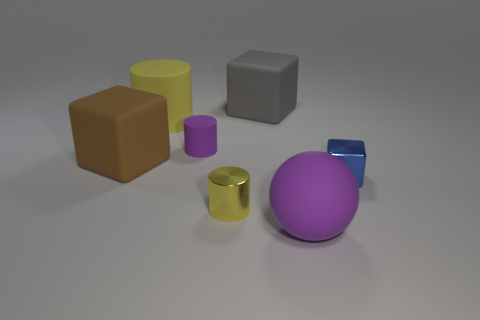Subtract 1 cylinders. How many cylinders are left? 2 Subtract all small yellow metallic cylinders. How many cylinders are left? 2 Add 2 big matte things. How many objects exist? 9 Subtract all cylinders. How many objects are left? 4 Subtract 0 blue cylinders. How many objects are left? 7 Subtract all blue objects. Subtract all tiny blue objects. How many objects are left? 5 Add 4 rubber cubes. How many rubber cubes are left? 6 Add 2 tiny cyan metal things. How many tiny cyan metal things exist? 2 